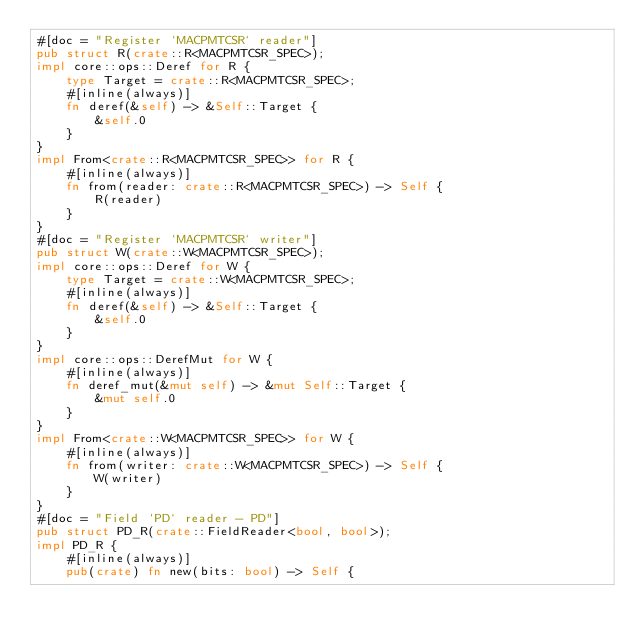Convert code to text. <code><loc_0><loc_0><loc_500><loc_500><_Rust_>#[doc = "Register `MACPMTCSR` reader"]
pub struct R(crate::R<MACPMTCSR_SPEC>);
impl core::ops::Deref for R {
    type Target = crate::R<MACPMTCSR_SPEC>;
    #[inline(always)]
    fn deref(&self) -> &Self::Target {
        &self.0
    }
}
impl From<crate::R<MACPMTCSR_SPEC>> for R {
    #[inline(always)]
    fn from(reader: crate::R<MACPMTCSR_SPEC>) -> Self {
        R(reader)
    }
}
#[doc = "Register `MACPMTCSR` writer"]
pub struct W(crate::W<MACPMTCSR_SPEC>);
impl core::ops::Deref for W {
    type Target = crate::W<MACPMTCSR_SPEC>;
    #[inline(always)]
    fn deref(&self) -> &Self::Target {
        &self.0
    }
}
impl core::ops::DerefMut for W {
    #[inline(always)]
    fn deref_mut(&mut self) -> &mut Self::Target {
        &mut self.0
    }
}
impl From<crate::W<MACPMTCSR_SPEC>> for W {
    #[inline(always)]
    fn from(writer: crate::W<MACPMTCSR_SPEC>) -> Self {
        W(writer)
    }
}
#[doc = "Field `PD` reader - PD"]
pub struct PD_R(crate::FieldReader<bool, bool>);
impl PD_R {
    #[inline(always)]
    pub(crate) fn new(bits: bool) -> Self {</code> 